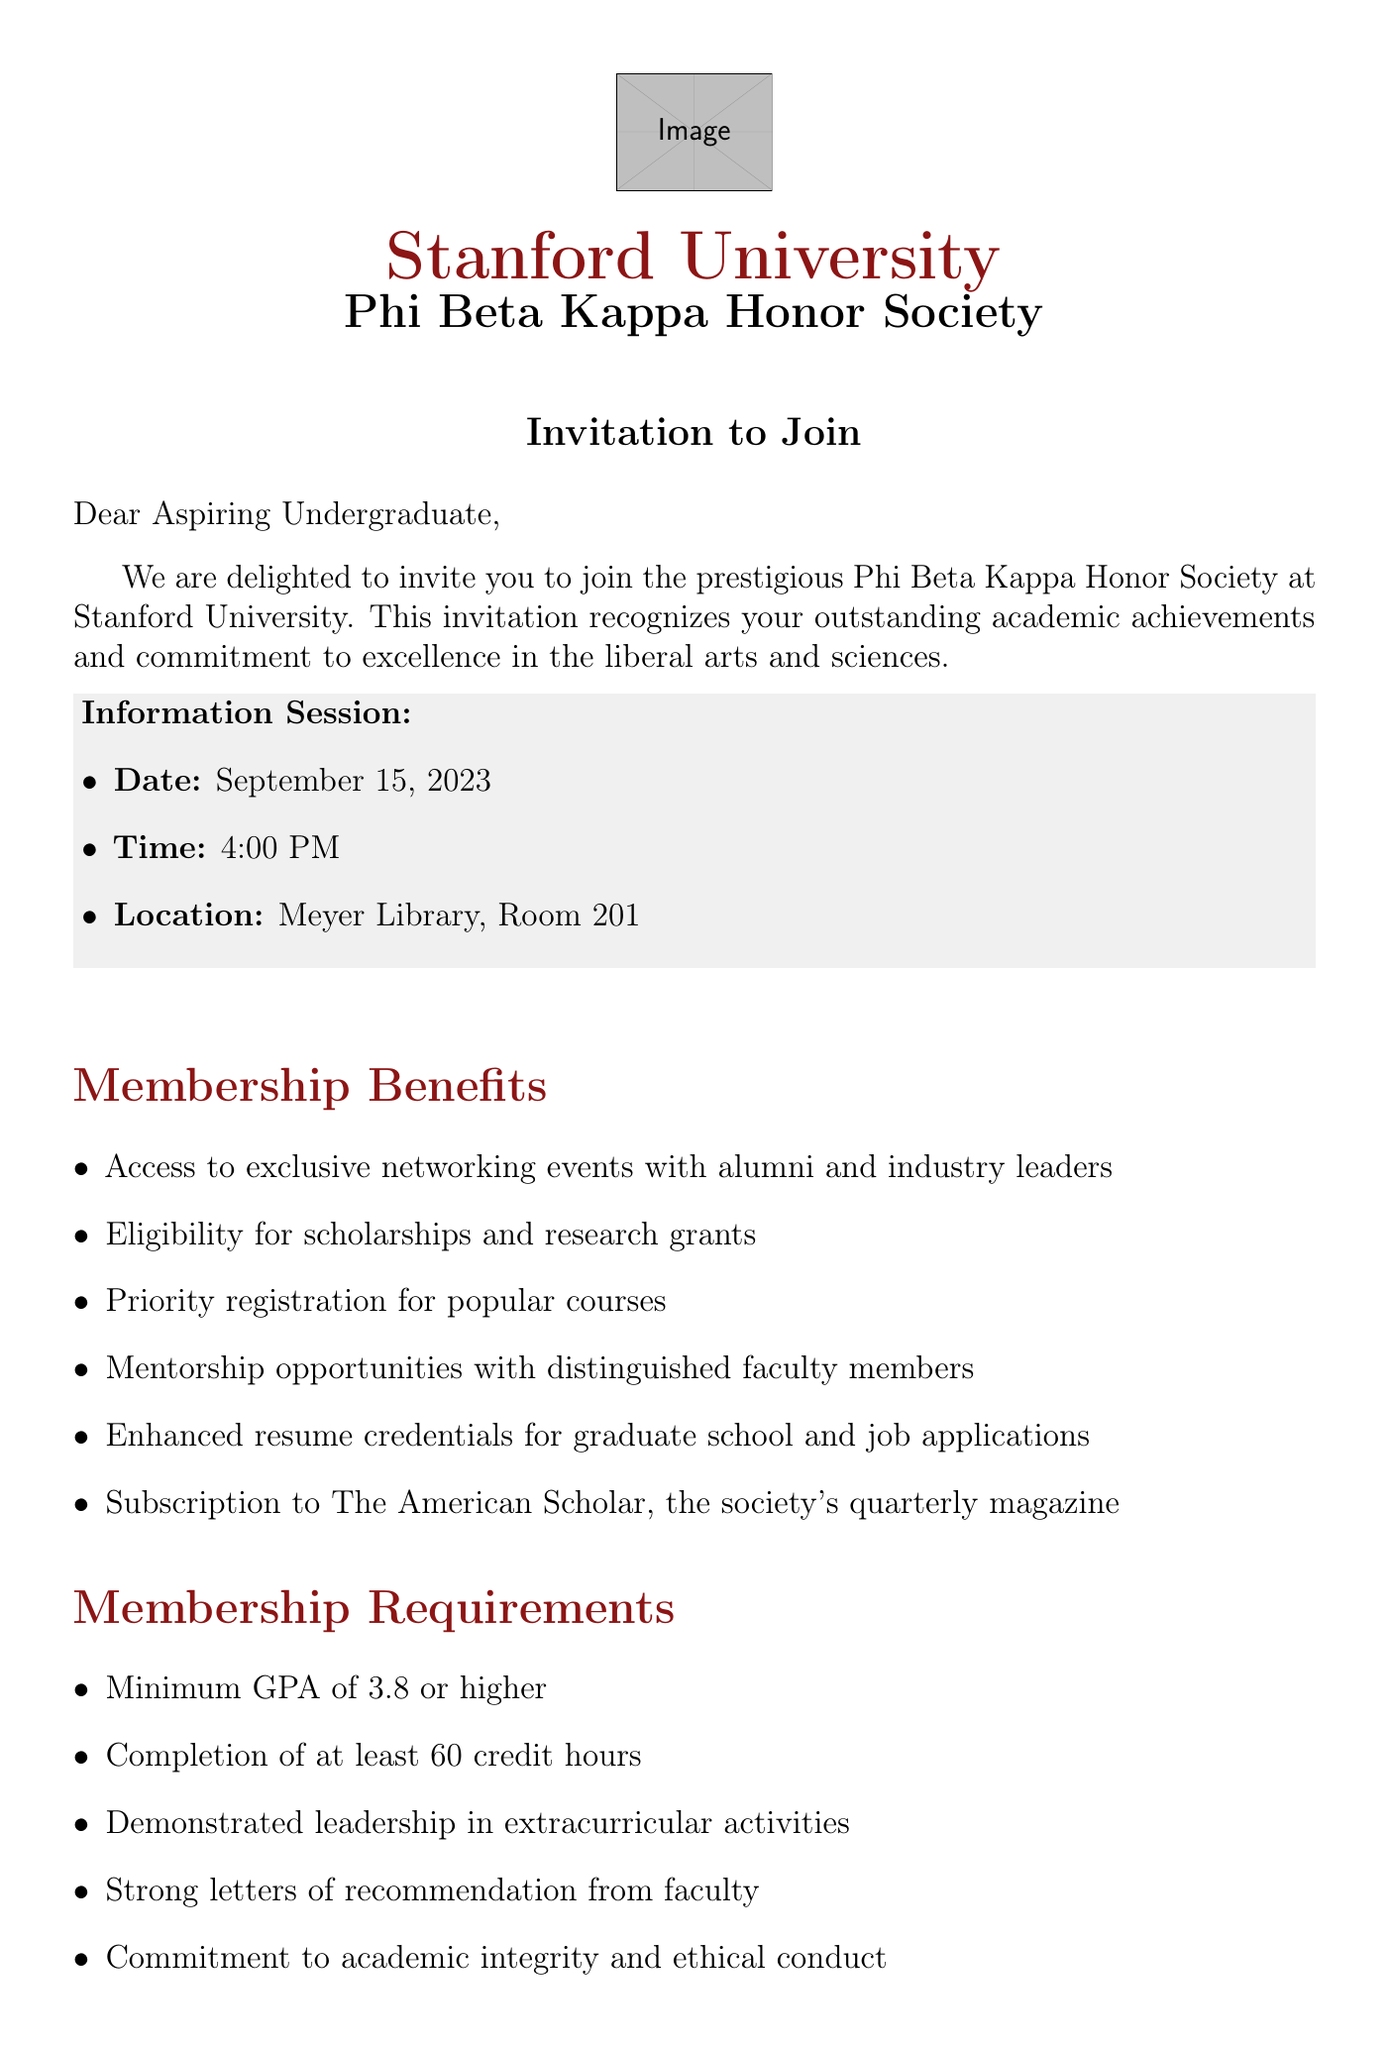What is the name of the honor society? The honor society mentioned in the document is Phi Beta Kappa.
Answer: Phi Beta Kappa What is the minimum GPA required for membership? The document specifies a minimum GPA requirement for membership as 3.8 or higher.
Answer: 3.8 When is the application deadline? The application deadline provided in the document is October 1, 2023.
Answer: October 1, 2023 Who is the current chapter president? The document states that Dr. Elizabeth Chen is the current chapter president.
Answer: Dr. Elizabeth Chen What are two benefits of membership? The document lists many benefits, two of which are "Access to exclusive networking events" and "Eligibility for scholarships and research grants."
Answer: Access to exclusive networking events, Eligibility for scholarships and research grants What documents are required for the application? The document outlines several required documents including an official transcript, personal statement, and two letters of recommendation.
Answer: Official transcript, personal statement, two letters of recommendation What is the mission of Phi Beta Kappa? The document states that the mission is to recognize and promote excellence in the liberal arts and sciences.
Answer: To recognize and promote excellence in the liberal arts and sciences Where will the information session be held? The document specifies that the information session will take place at Meyer Library, Room 201.
Answer: Meyer Library, Room 201 